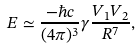Convert formula to latex. <formula><loc_0><loc_0><loc_500><loc_500>E \simeq \frac { - \hbar { c } } { ( 4 \pi ) ^ { 3 } } \gamma \frac { V _ { 1 } V _ { 2 } } { R ^ { 7 } } ,</formula> 